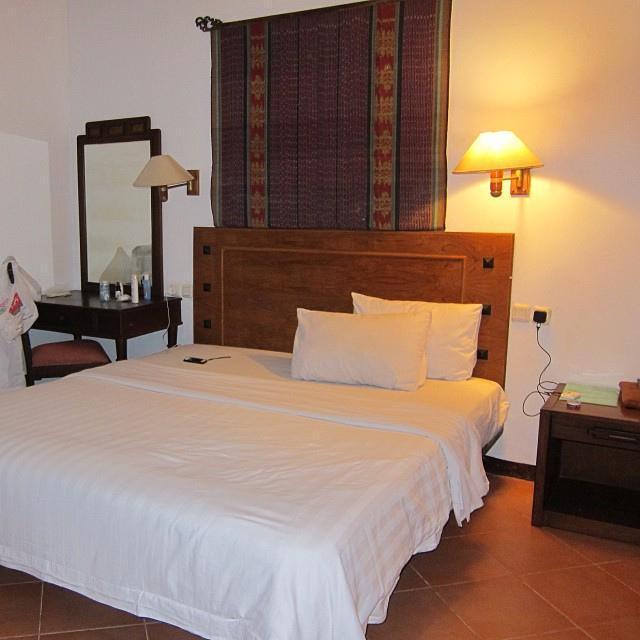How many lights are turned on?
Give a very brief answer. 1. How many chairs are there?
Give a very brief answer. 1. 